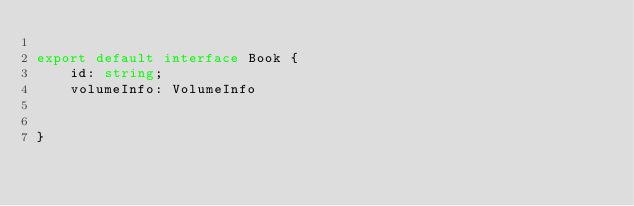<code> <loc_0><loc_0><loc_500><loc_500><_TypeScript_>
export default interface Book {
    id: string;
    volumeInfo: VolumeInfo


}</code> 